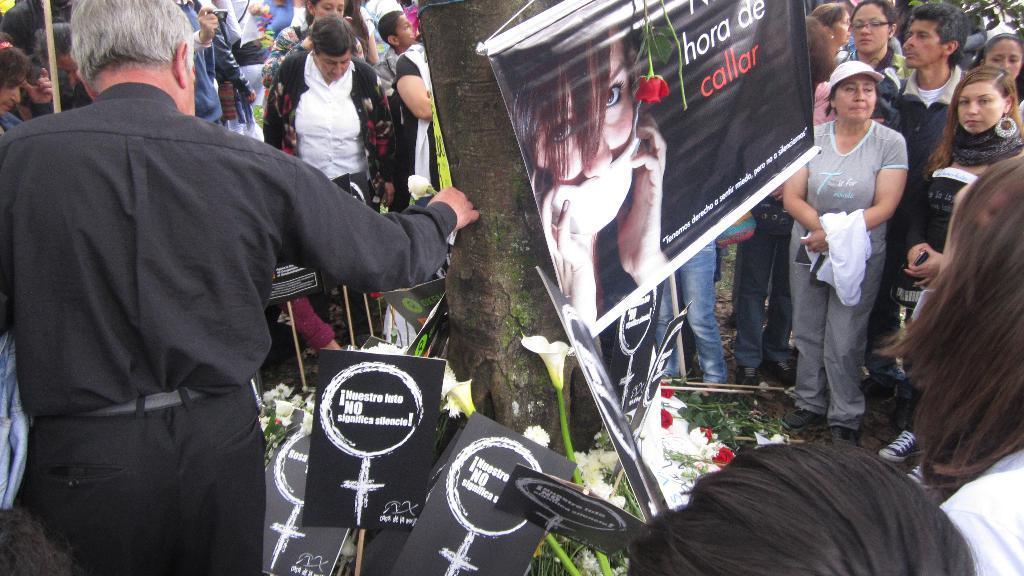How would you summarize this image in a sentence or two? This image is taken outdoors. In the background many people are standing on the ground. In the middle of the image there is a tree and there are a few placards and flowers on the ground and there is a banner with a text and a picture on it. On the left side of the image a man is standing on the ground. 